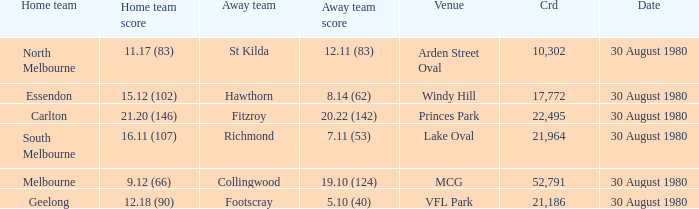What was the score for south melbourne at home? 16.11 (107). 